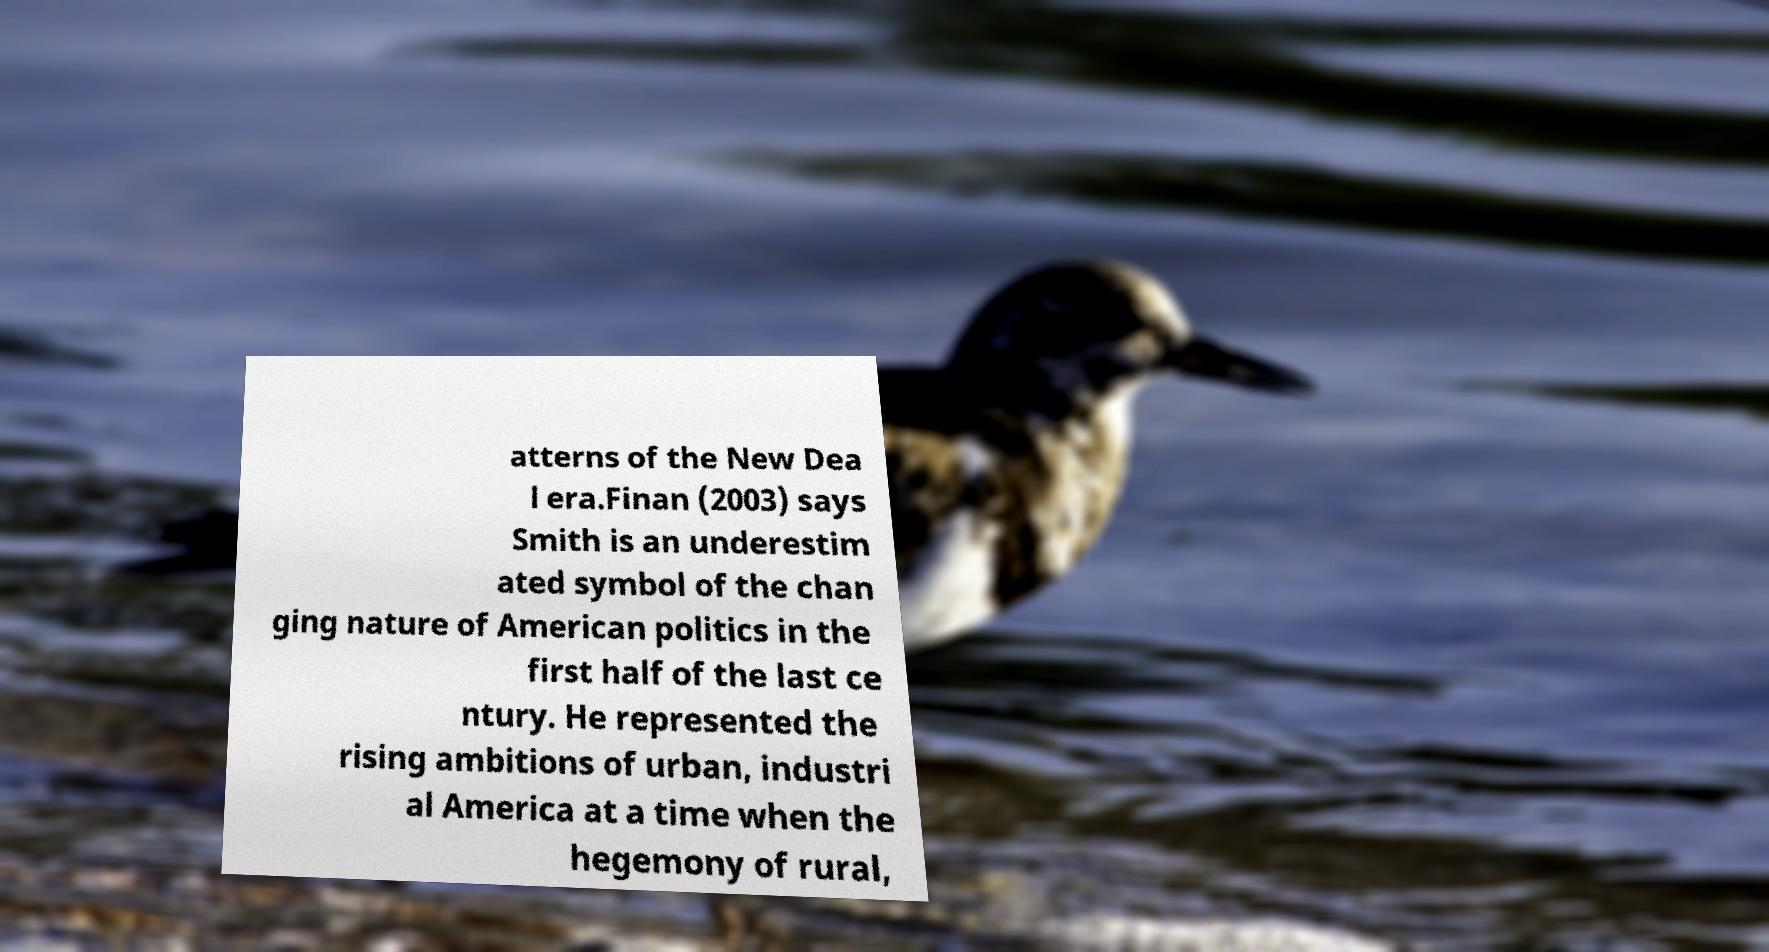Can you read and provide the text displayed in the image?This photo seems to have some interesting text. Can you extract and type it out for me? atterns of the New Dea l era.Finan (2003) says Smith is an underestim ated symbol of the chan ging nature of American politics in the first half of the last ce ntury. He represented the rising ambitions of urban, industri al America at a time when the hegemony of rural, 